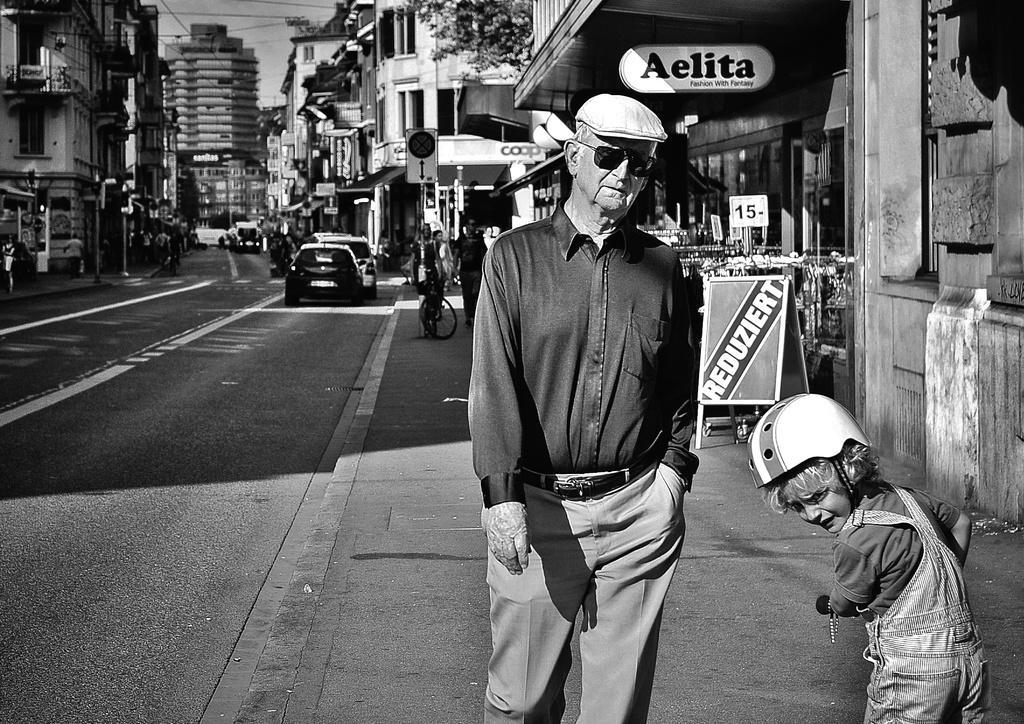In one or two sentences, can you explain what this image depicts? This is a black and white image. On the left side of the image we can see buildings and poles. On the right side of the image we can see persons, vehicles, buildings and name boards. In the background we can see buildings and sky. In the center of the image we can see vehicles on the road. 